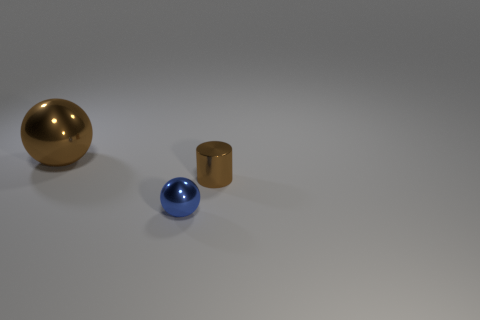What number of other metallic balls have the same size as the brown ball? There are no other metallic balls in the image that have the same size as the brown ball. 